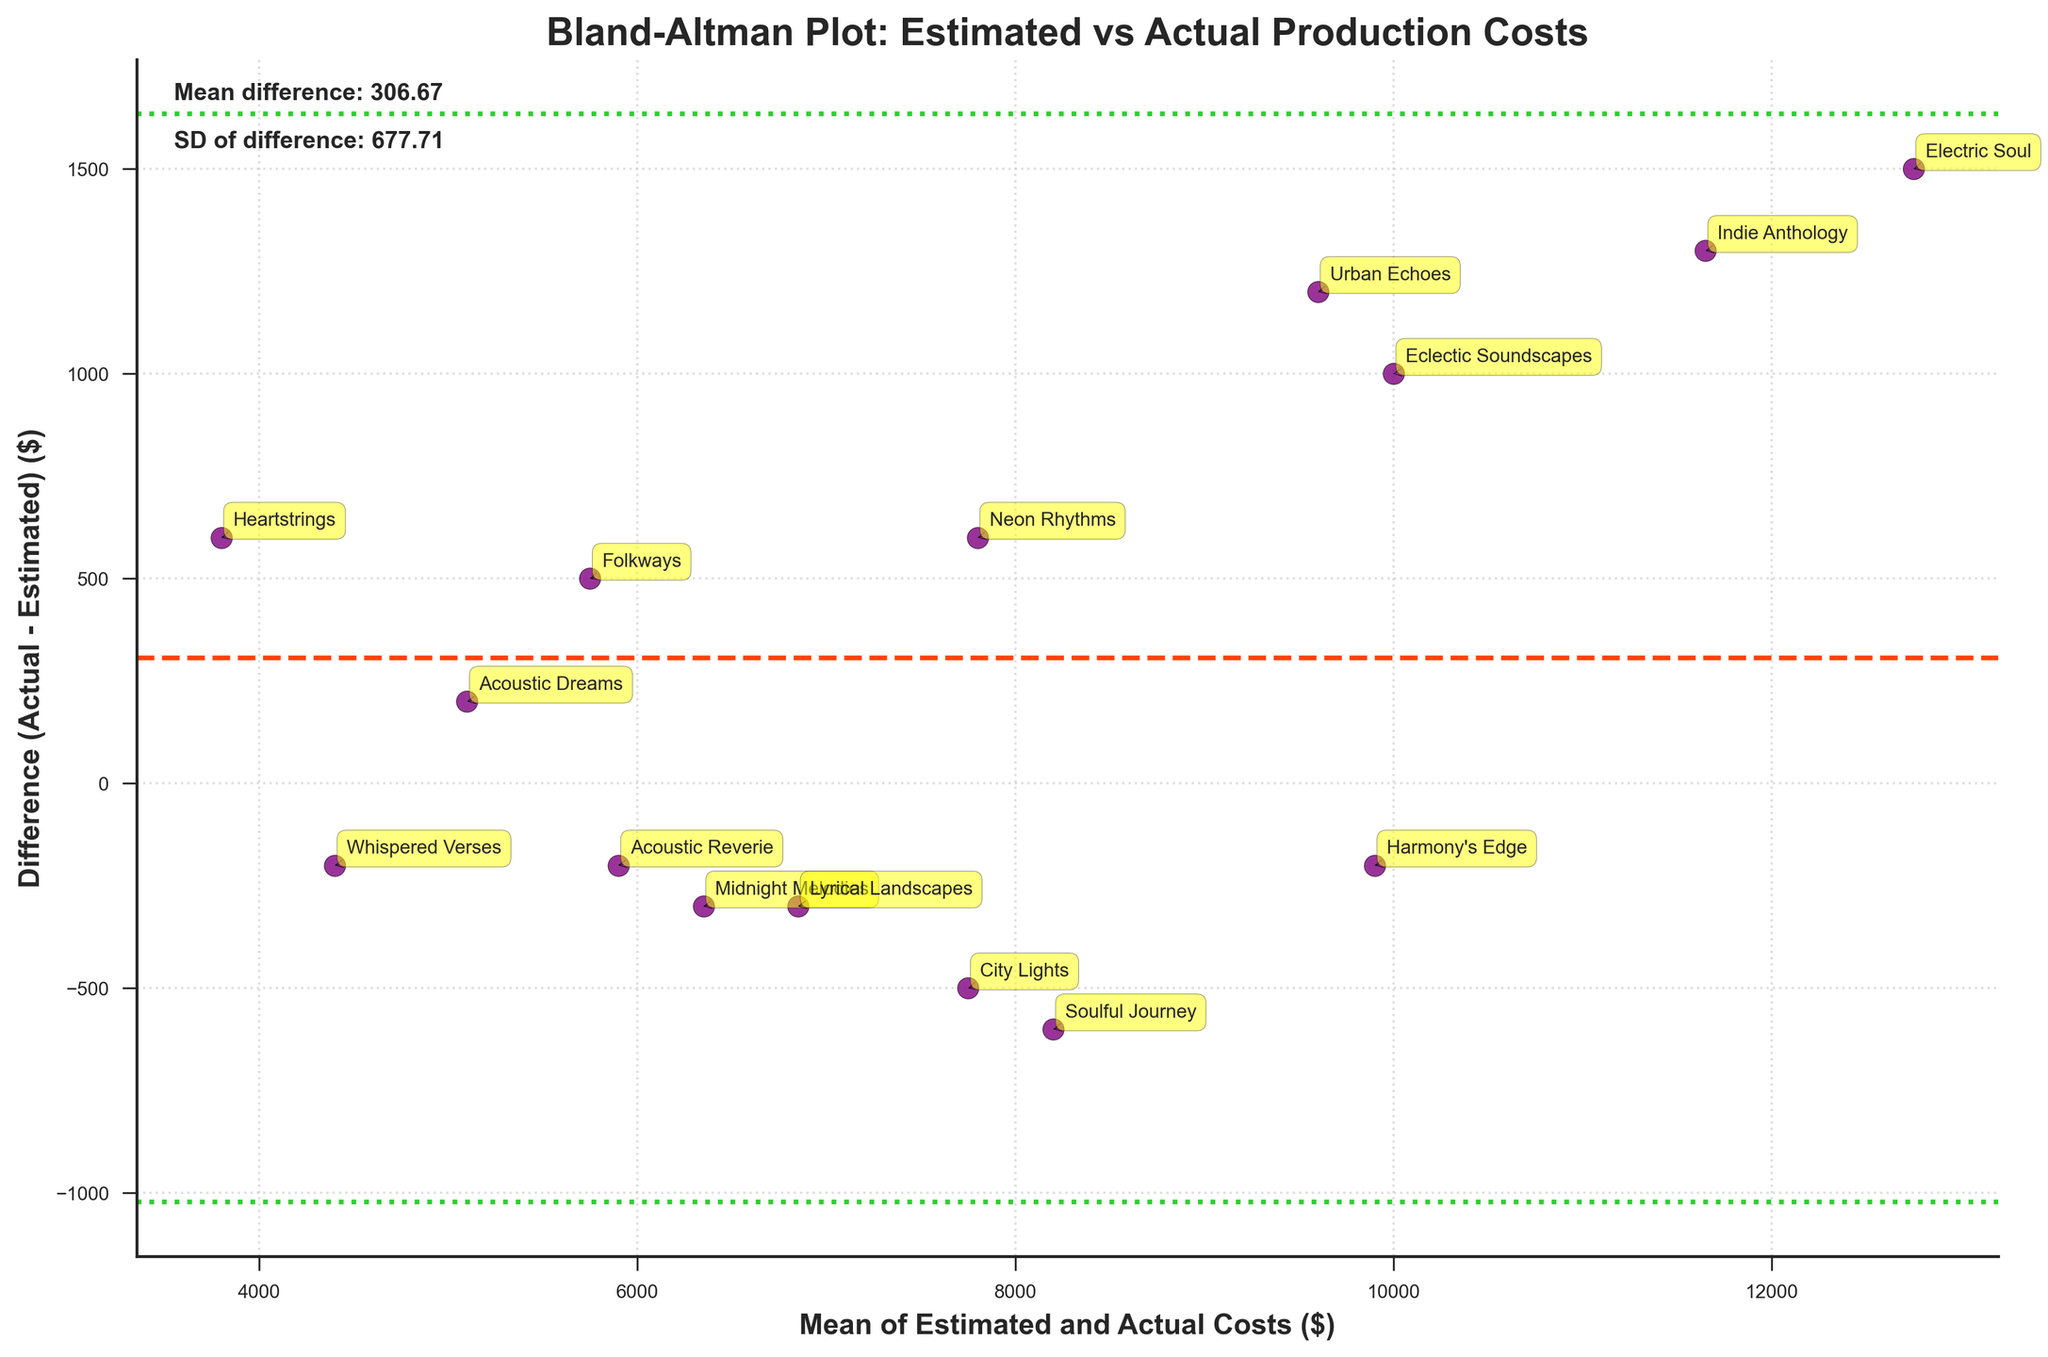How many data points are plotted in the figure? The number of data points corresponds to the number of albums listed in the data. By counting the unique album titles, we find there are 15 albums, meaning 15 data points are plotted.
Answer: 15 What does the horizontal dashed line in the plot represent? The horizontal dashed line represents the mean difference between the actual and estimated costs for the production of the albums. This line shows the average bias in the cost estimates.
Answer: Mean difference Which album has the largest positive difference between actual and estimated costs? By examining the data points in the plot, the album with the largest positive difference between the actual and estimated costs is "Electric Soul". It has the highest vertical distance above the mean difference line.
Answer: Electric Soul What do the dotted lines in the plot indicate? The dotted lines represent the limits of agreement. They are placed at the mean difference plus and minus 1.96 times the standard deviation of the differences. These lines help in understanding the range within which most differences between actual and estimated costs lie.
Answer: Limits of agreement Which albums have actual costs very close to their estimated costs? Looking at the data points that lie close to the mean difference line, "Midnight Melodies", "Harmony's Edge", and "Whispered Verses" have differences that are very small, indicating their actual costs are close to the estimated costs.
Answer: Midnight Melodies, Harmony's Edge, Whispered Verses Is there an album with a negative difference between actual and estimated costs? If so, name one. The plot shows data points below the horizontal mean difference line. One such album is "City Lights", indicating its actual cost is less than the estimated cost.
Answer: City Lights What is the mean of the actual and estimated costs for "Neon Rhythms"? To find the mean, add the actual cost and estimated cost for "Neon Rhythms" (8100 + 7500 = 15600) and divide by 2. This gives a mean of 7800.
Answer: 7800 How are the mean difference and standard deviation of the differences annotated in the plot? The mean difference and standard deviation are annotated in the upper left corner of the plot. They are displayed as textual information, "Mean difference: X.XX" and "SD of difference: Y.YY" respectively.
Answer: Annotated in text 